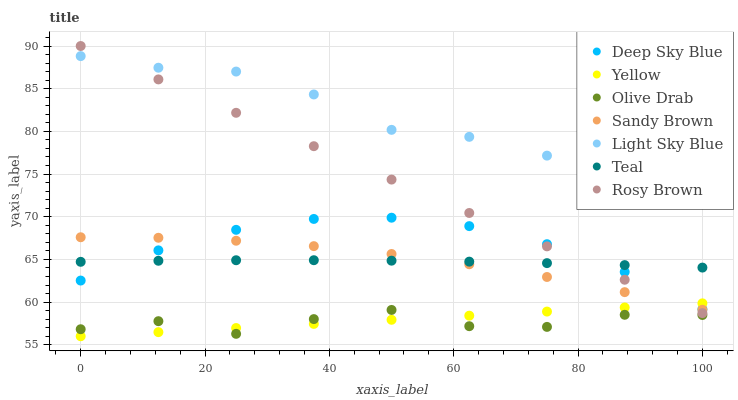Does Olive Drab have the minimum area under the curve?
Answer yes or no. Yes. Does Light Sky Blue have the maximum area under the curve?
Answer yes or no. Yes. Does Rosy Brown have the minimum area under the curve?
Answer yes or no. No. Does Rosy Brown have the maximum area under the curve?
Answer yes or no. No. Is Yellow the smoothest?
Answer yes or no. Yes. Is Olive Drab the roughest?
Answer yes or no. Yes. Is Rosy Brown the smoothest?
Answer yes or no. No. Is Rosy Brown the roughest?
Answer yes or no. No. Does Yellow have the lowest value?
Answer yes or no. Yes. Does Rosy Brown have the lowest value?
Answer yes or no. No. Does Rosy Brown have the highest value?
Answer yes or no. Yes. Does Yellow have the highest value?
Answer yes or no. No. Is Olive Drab less than Deep Sky Blue?
Answer yes or no. Yes. Is Light Sky Blue greater than Deep Sky Blue?
Answer yes or no. Yes. Does Sandy Brown intersect Teal?
Answer yes or no. Yes. Is Sandy Brown less than Teal?
Answer yes or no. No. Is Sandy Brown greater than Teal?
Answer yes or no. No. Does Olive Drab intersect Deep Sky Blue?
Answer yes or no. No. 